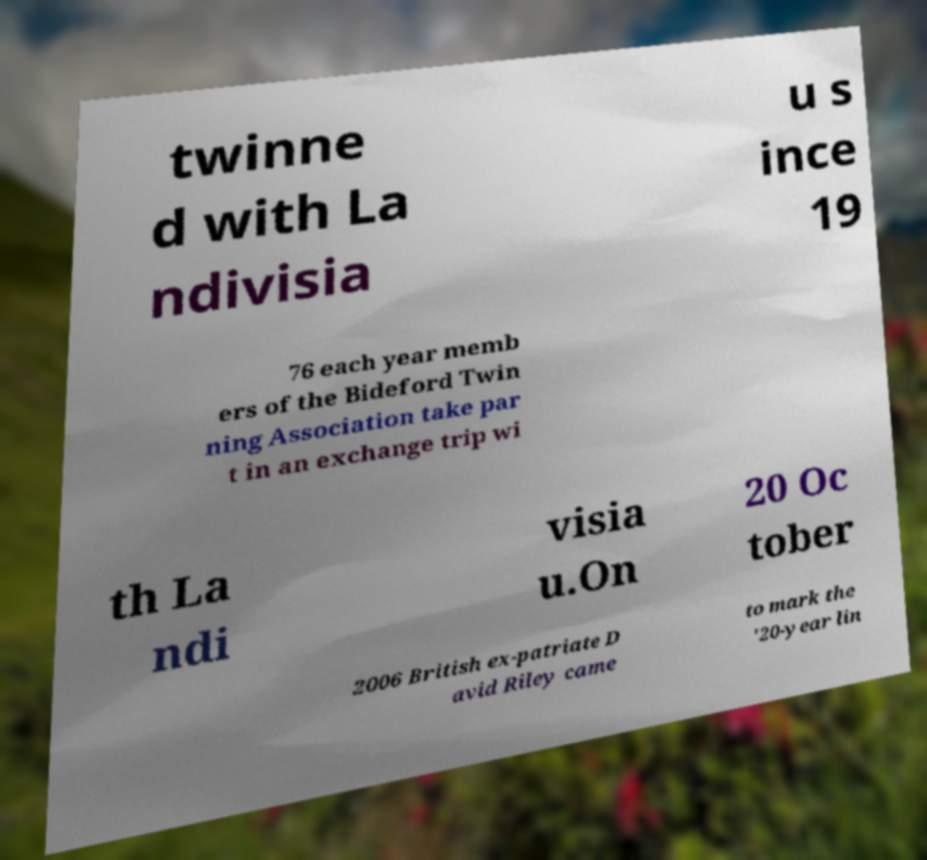Can you read and provide the text displayed in the image?This photo seems to have some interesting text. Can you extract and type it out for me? twinne d with La ndivisia u s ince 19 76 each year memb ers of the Bideford Twin ning Association take par t in an exchange trip wi th La ndi visia u.On 20 Oc tober 2006 British ex-patriate D avid Riley came to mark the '20-year lin 